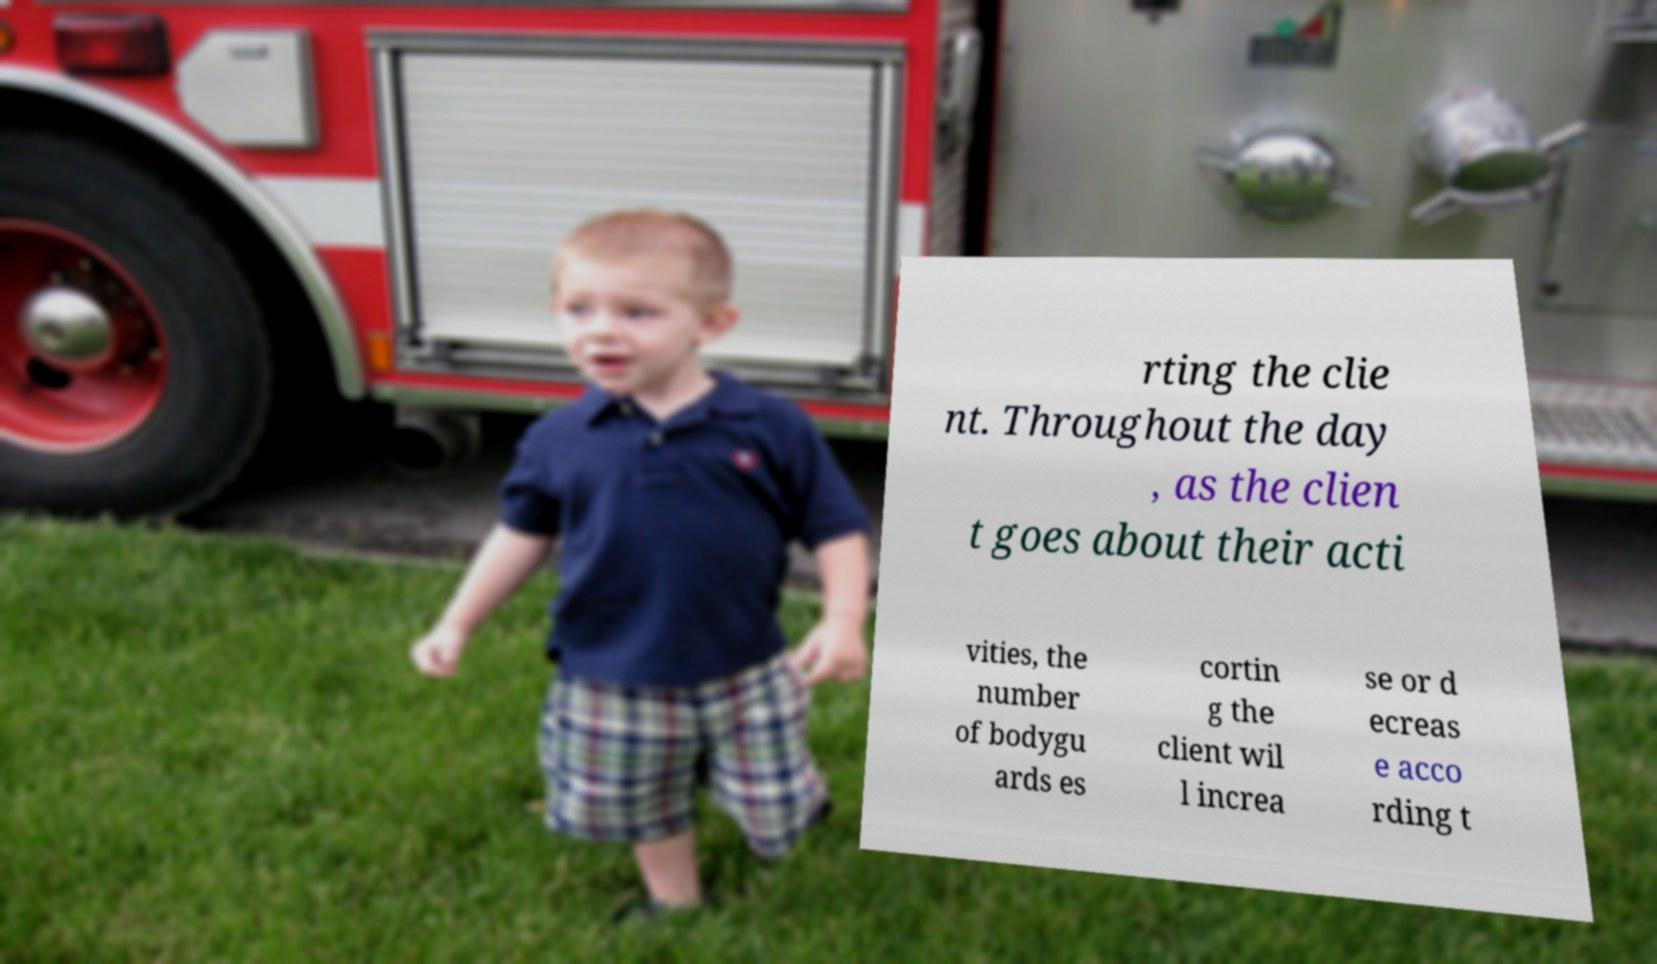What messages or text are displayed in this image? I need them in a readable, typed format. rting the clie nt. Throughout the day , as the clien t goes about their acti vities, the number of bodygu ards es cortin g the client wil l increa se or d ecreas e acco rding t 